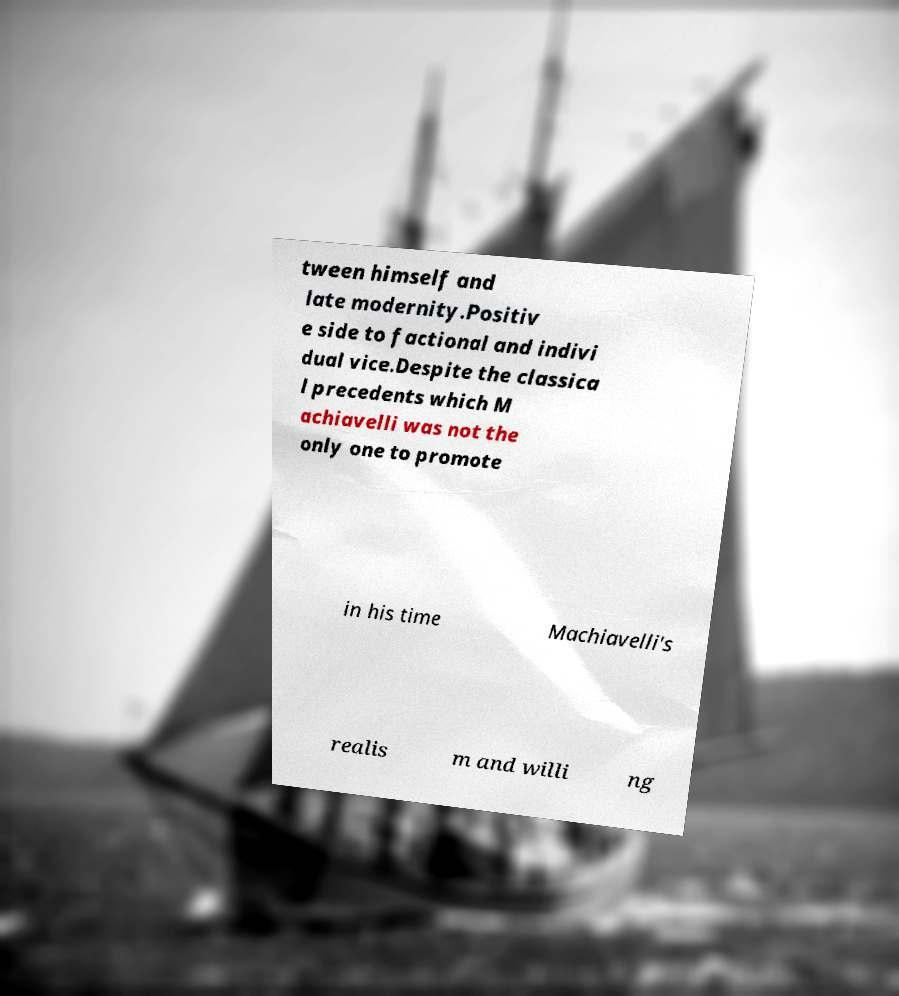There's text embedded in this image that I need extracted. Can you transcribe it verbatim? tween himself and late modernity.Positiv e side to factional and indivi dual vice.Despite the classica l precedents which M achiavelli was not the only one to promote in his time Machiavelli's realis m and willi ng 